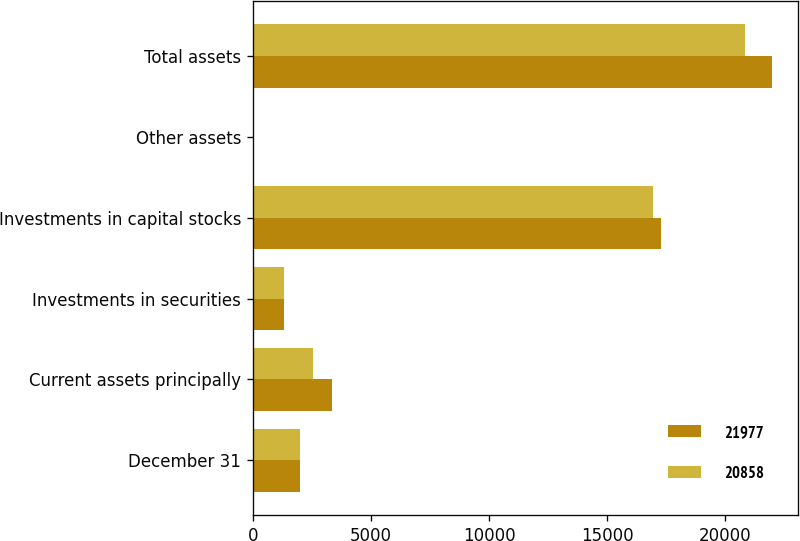Convert chart. <chart><loc_0><loc_0><loc_500><loc_500><stacked_bar_chart><ecel><fcel>December 31<fcel>Current assets principally<fcel>Investments in securities<fcel>Investments in capital stocks<fcel>Other assets<fcel>Total assets<nl><fcel>21977<fcel>2013<fcel>3350<fcel>1330<fcel>17264<fcel>33<fcel>21977<nl><fcel>20858<fcel>2012<fcel>2556<fcel>1332<fcel>16936<fcel>34<fcel>20858<nl></chart> 